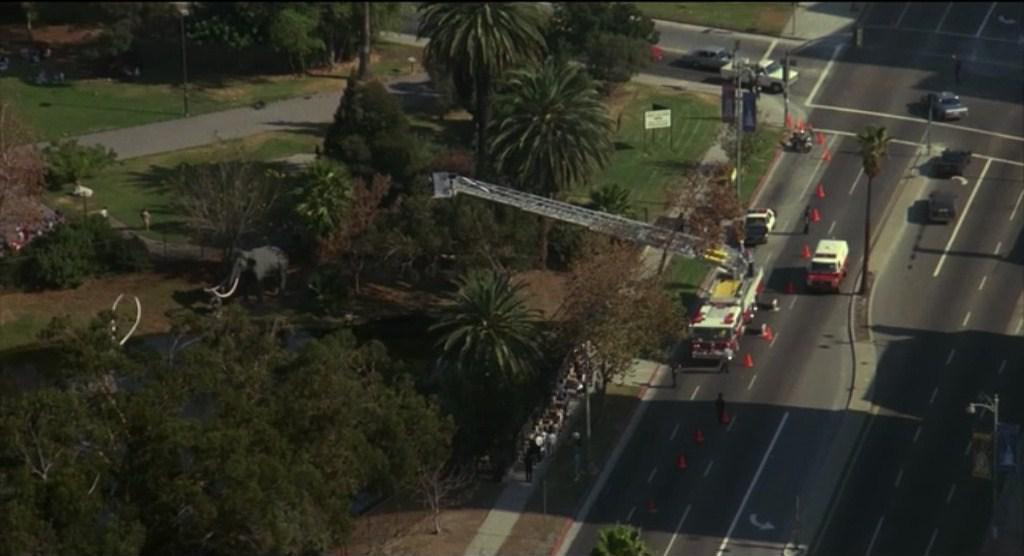In one or two sentences, can you explain what this image depicts? In this image I can see the road. On the road I can see many vehicles and the traffic cones. To the side of the road I can see many trees and also the poles. In the background I can see the ground. 